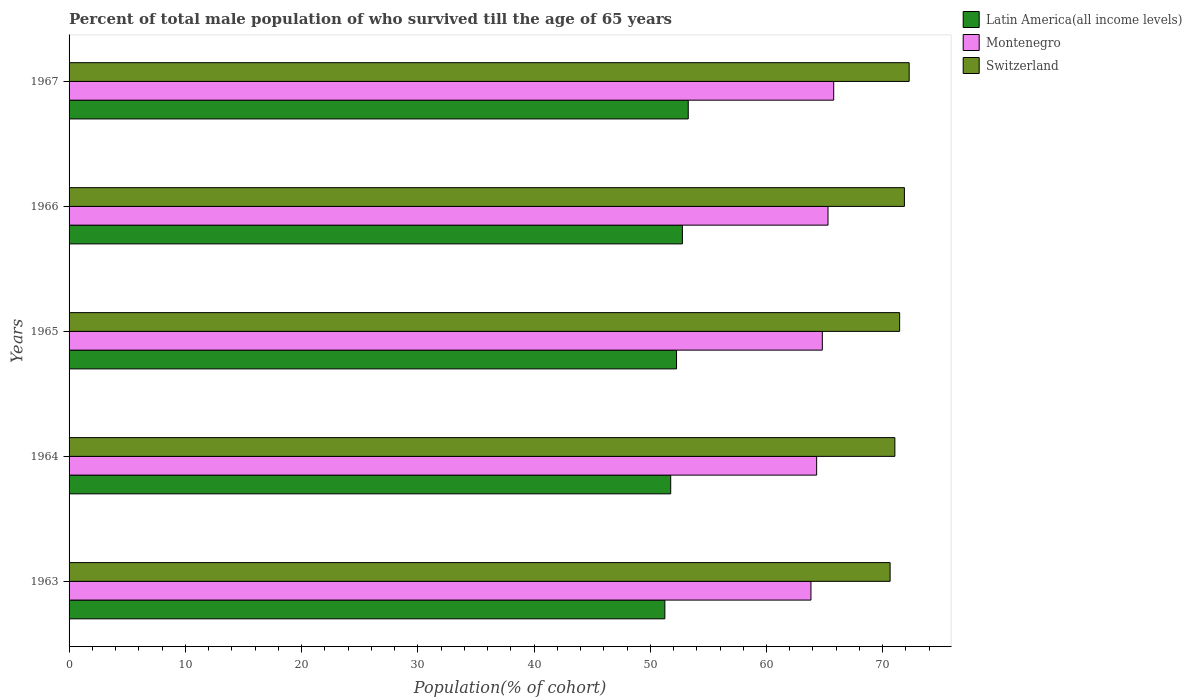How many different coloured bars are there?
Make the answer very short. 3. How many groups of bars are there?
Make the answer very short. 5. How many bars are there on the 4th tick from the top?
Offer a very short reply. 3. How many bars are there on the 4th tick from the bottom?
Your response must be concise. 3. What is the label of the 4th group of bars from the top?
Your response must be concise. 1964. In how many cases, is the number of bars for a given year not equal to the number of legend labels?
Offer a very short reply. 0. What is the percentage of total male population who survived till the age of 65 years in Montenegro in 1966?
Offer a terse response. 65.29. Across all years, what is the maximum percentage of total male population who survived till the age of 65 years in Montenegro?
Ensure brevity in your answer.  65.78. Across all years, what is the minimum percentage of total male population who survived till the age of 65 years in Latin America(all income levels)?
Your answer should be very brief. 51.26. In which year was the percentage of total male population who survived till the age of 65 years in Switzerland maximum?
Offer a terse response. 1967. In which year was the percentage of total male population who survived till the age of 65 years in Latin America(all income levels) minimum?
Keep it short and to the point. 1963. What is the total percentage of total male population who survived till the age of 65 years in Montenegro in the graph?
Ensure brevity in your answer.  324.02. What is the difference between the percentage of total male population who survived till the age of 65 years in Montenegro in 1963 and that in 1965?
Ensure brevity in your answer.  -0.98. What is the difference between the percentage of total male population who survived till the age of 65 years in Switzerland in 1966 and the percentage of total male population who survived till the age of 65 years in Montenegro in 1965?
Make the answer very short. 7.06. What is the average percentage of total male population who survived till the age of 65 years in Montenegro per year?
Ensure brevity in your answer.  64.8. In the year 1963, what is the difference between the percentage of total male population who survived till the age of 65 years in Montenegro and percentage of total male population who survived till the age of 65 years in Latin America(all income levels)?
Your answer should be compact. 12.57. What is the ratio of the percentage of total male population who survived till the age of 65 years in Montenegro in 1964 to that in 1966?
Your answer should be very brief. 0.99. Is the percentage of total male population who survived till the age of 65 years in Latin America(all income levels) in 1963 less than that in 1967?
Your answer should be very brief. Yes. Is the difference between the percentage of total male population who survived till the age of 65 years in Montenegro in 1966 and 1967 greater than the difference between the percentage of total male population who survived till the age of 65 years in Latin America(all income levels) in 1966 and 1967?
Your answer should be very brief. Yes. What is the difference between the highest and the second highest percentage of total male population who survived till the age of 65 years in Latin America(all income levels)?
Offer a very short reply. 0.5. What is the difference between the highest and the lowest percentage of total male population who survived till the age of 65 years in Montenegro?
Your answer should be very brief. 1.96. In how many years, is the percentage of total male population who survived till the age of 65 years in Switzerland greater than the average percentage of total male population who survived till the age of 65 years in Switzerland taken over all years?
Keep it short and to the point. 3. What does the 1st bar from the top in 1964 represents?
Ensure brevity in your answer.  Switzerland. What does the 3rd bar from the bottom in 1964 represents?
Offer a terse response. Switzerland. Is it the case that in every year, the sum of the percentage of total male population who survived till the age of 65 years in Montenegro and percentage of total male population who survived till the age of 65 years in Switzerland is greater than the percentage of total male population who survived till the age of 65 years in Latin America(all income levels)?
Provide a succinct answer. Yes. How many bars are there?
Your response must be concise. 15. Are all the bars in the graph horizontal?
Your response must be concise. Yes. How many years are there in the graph?
Provide a succinct answer. 5. Are the values on the major ticks of X-axis written in scientific E-notation?
Offer a very short reply. No. Does the graph contain any zero values?
Your answer should be compact. No. Does the graph contain grids?
Your response must be concise. No. How many legend labels are there?
Offer a very short reply. 3. What is the title of the graph?
Ensure brevity in your answer.  Percent of total male population of who survived till the age of 65 years. Does "Tajikistan" appear as one of the legend labels in the graph?
Offer a terse response. No. What is the label or title of the X-axis?
Offer a terse response. Population(% of cohort). What is the Population(% of cohort) in Latin America(all income levels) in 1963?
Provide a short and direct response. 51.26. What is the Population(% of cohort) of Montenegro in 1963?
Your answer should be compact. 63.83. What is the Population(% of cohort) in Switzerland in 1963?
Offer a terse response. 70.63. What is the Population(% of cohort) in Latin America(all income levels) in 1964?
Offer a very short reply. 51.76. What is the Population(% of cohort) of Montenegro in 1964?
Give a very brief answer. 64.31. What is the Population(% of cohort) in Switzerland in 1964?
Offer a very short reply. 71.04. What is the Population(% of cohort) in Latin America(all income levels) in 1965?
Provide a short and direct response. 52.26. What is the Population(% of cohort) of Montenegro in 1965?
Keep it short and to the point. 64.8. What is the Population(% of cohort) in Switzerland in 1965?
Your answer should be very brief. 71.46. What is the Population(% of cohort) of Latin America(all income levels) in 1966?
Give a very brief answer. 52.76. What is the Population(% of cohort) in Montenegro in 1966?
Provide a short and direct response. 65.29. What is the Population(% of cohort) in Switzerland in 1966?
Provide a short and direct response. 71.87. What is the Population(% of cohort) of Latin America(all income levels) in 1967?
Provide a short and direct response. 53.27. What is the Population(% of cohort) in Montenegro in 1967?
Give a very brief answer. 65.78. What is the Population(% of cohort) in Switzerland in 1967?
Give a very brief answer. 72.28. Across all years, what is the maximum Population(% of cohort) in Latin America(all income levels)?
Offer a very short reply. 53.27. Across all years, what is the maximum Population(% of cohort) of Montenegro?
Make the answer very short. 65.78. Across all years, what is the maximum Population(% of cohort) in Switzerland?
Make the answer very short. 72.28. Across all years, what is the minimum Population(% of cohort) of Latin America(all income levels)?
Ensure brevity in your answer.  51.26. Across all years, what is the minimum Population(% of cohort) in Montenegro?
Your answer should be very brief. 63.83. Across all years, what is the minimum Population(% of cohort) of Switzerland?
Offer a terse response. 70.63. What is the total Population(% of cohort) in Latin America(all income levels) in the graph?
Give a very brief answer. 261.31. What is the total Population(% of cohort) of Montenegro in the graph?
Provide a succinct answer. 324.02. What is the total Population(% of cohort) in Switzerland in the graph?
Keep it short and to the point. 357.28. What is the difference between the Population(% of cohort) of Latin America(all income levels) in 1963 and that in 1964?
Your answer should be very brief. -0.5. What is the difference between the Population(% of cohort) in Montenegro in 1963 and that in 1964?
Provide a short and direct response. -0.49. What is the difference between the Population(% of cohort) in Switzerland in 1963 and that in 1964?
Keep it short and to the point. -0.41. What is the difference between the Population(% of cohort) in Latin America(all income levels) in 1963 and that in 1965?
Your answer should be very brief. -1.01. What is the difference between the Population(% of cohort) of Montenegro in 1963 and that in 1965?
Ensure brevity in your answer.  -0.98. What is the difference between the Population(% of cohort) of Switzerland in 1963 and that in 1965?
Your answer should be compact. -0.82. What is the difference between the Population(% of cohort) of Latin America(all income levels) in 1963 and that in 1966?
Provide a succinct answer. -1.51. What is the difference between the Population(% of cohort) in Montenegro in 1963 and that in 1966?
Your answer should be very brief. -1.47. What is the difference between the Population(% of cohort) in Switzerland in 1963 and that in 1966?
Give a very brief answer. -1.23. What is the difference between the Population(% of cohort) of Latin America(all income levels) in 1963 and that in 1967?
Your response must be concise. -2.01. What is the difference between the Population(% of cohort) of Montenegro in 1963 and that in 1967?
Ensure brevity in your answer.  -1.96. What is the difference between the Population(% of cohort) of Switzerland in 1963 and that in 1967?
Offer a terse response. -1.64. What is the difference between the Population(% of cohort) in Latin America(all income levels) in 1964 and that in 1965?
Your response must be concise. -0.5. What is the difference between the Population(% of cohort) of Montenegro in 1964 and that in 1965?
Provide a short and direct response. -0.49. What is the difference between the Population(% of cohort) of Switzerland in 1964 and that in 1965?
Keep it short and to the point. -0.41. What is the difference between the Population(% of cohort) of Latin America(all income levels) in 1964 and that in 1966?
Your answer should be very brief. -1.01. What is the difference between the Population(% of cohort) of Montenegro in 1964 and that in 1966?
Offer a terse response. -0.98. What is the difference between the Population(% of cohort) of Switzerland in 1964 and that in 1966?
Your answer should be compact. -0.82. What is the difference between the Population(% of cohort) of Latin America(all income levels) in 1964 and that in 1967?
Make the answer very short. -1.51. What is the difference between the Population(% of cohort) in Montenegro in 1964 and that in 1967?
Your answer should be compact. -1.47. What is the difference between the Population(% of cohort) in Switzerland in 1964 and that in 1967?
Keep it short and to the point. -1.23. What is the difference between the Population(% of cohort) of Latin America(all income levels) in 1965 and that in 1966?
Your answer should be compact. -0.5. What is the difference between the Population(% of cohort) of Montenegro in 1965 and that in 1966?
Offer a very short reply. -0.49. What is the difference between the Population(% of cohort) in Switzerland in 1965 and that in 1966?
Provide a short and direct response. -0.41. What is the difference between the Population(% of cohort) of Latin America(all income levels) in 1965 and that in 1967?
Keep it short and to the point. -1.01. What is the difference between the Population(% of cohort) of Montenegro in 1965 and that in 1967?
Provide a short and direct response. -0.98. What is the difference between the Population(% of cohort) in Switzerland in 1965 and that in 1967?
Provide a succinct answer. -0.82. What is the difference between the Population(% of cohort) in Latin America(all income levels) in 1966 and that in 1967?
Make the answer very short. -0.5. What is the difference between the Population(% of cohort) of Montenegro in 1966 and that in 1967?
Ensure brevity in your answer.  -0.49. What is the difference between the Population(% of cohort) of Switzerland in 1966 and that in 1967?
Offer a terse response. -0.41. What is the difference between the Population(% of cohort) of Latin America(all income levels) in 1963 and the Population(% of cohort) of Montenegro in 1964?
Make the answer very short. -13.06. What is the difference between the Population(% of cohort) in Latin America(all income levels) in 1963 and the Population(% of cohort) in Switzerland in 1964?
Offer a very short reply. -19.79. What is the difference between the Population(% of cohort) in Montenegro in 1963 and the Population(% of cohort) in Switzerland in 1964?
Ensure brevity in your answer.  -7.22. What is the difference between the Population(% of cohort) in Latin America(all income levels) in 1963 and the Population(% of cohort) in Montenegro in 1965?
Your answer should be compact. -13.55. What is the difference between the Population(% of cohort) of Latin America(all income levels) in 1963 and the Population(% of cohort) of Switzerland in 1965?
Your response must be concise. -20.2. What is the difference between the Population(% of cohort) of Montenegro in 1963 and the Population(% of cohort) of Switzerland in 1965?
Make the answer very short. -7.63. What is the difference between the Population(% of cohort) of Latin America(all income levels) in 1963 and the Population(% of cohort) of Montenegro in 1966?
Keep it short and to the point. -14.04. What is the difference between the Population(% of cohort) in Latin America(all income levels) in 1963 and the Population(% of cohort) in Switzerland in 1966?
Ensure brevity in your answer.  -20.61. What is the difference between the Population(% of cohort) in Montenegro in 1963 and the Population(% of cohort) in Switzerland in 1966?
Ensure brevity in your answer.  -8.04. What is the difference between the Population(% of cohort) of Latin America(all income levels) in 1963 and the Population(% of cohort) of Montenegro in 1967?
Provide a short and direct response. -14.53. What is the difference between the Population(% of cohort) in Latin America(all income levels) in 1963 and the Population(% of cohort) in Switzerland in 1967?
Your answer should be compact. -21.02. What is the difference between the Population(% of cohort) in Montenegro in 1963 and the Population(% of cohort) in Switzerland in 1967?
Offer a very short reply. -8.45. What is the difference between the Population(% of cohort) in Latin America(all income levels) in 1964 and the Population(% of cohort) in Montenegro in 1965?
Make the answer very short. -13.04. What is the difference between the Population(% of cohort) in Latin America(all income levels) in 1964 and the Population(% of cohort) in Switzerland in 1965?
Your response must be concise. -19.7. What is the difference between the Population(% of cohort) of Montenegro in 1964 and the Population(% of cohort) of Switzerland in 1965?
Offer a terse response. -7.14. What is the difference between the Population(% of cohort) in Latin America(all income levels) in 1964 and the Population(% of cohort) in Montenegro in 1966?
Your answer should be very brief. -13.53. What is the difference between the Population(% of cohort) in Latin America(all income levels) in 1964 and the Population(% of cohort) in Switzerland in 1966?
Your answer should be compact. -20.11. What is the difference between the Population(% of cohort) of Montenegro in 1964 and the Population(% of cohort) of Switzerland in 1966?
Your response must be concise. -7.55. What is the difference between the Population(% of cohort) of Latin America(all income levels) in 1964 and the Population(% of cohort) of Montenegro in 1967?
Keep it short and to the point. -14.02. What is the difference between the Population(% of cohort) of Latin America(all income levels) in 1964 and the Population(% of cohort) of Switzerland in 1967?
Make the answer very short. -20.52. What is the difference between the Population(% of cohort) in Montenegro in 1964 and the Population(% of cohort) in Switzerland in 1967?
Offer a very short reply. -7.96. What is the difference between the Population(% of cohort) of Latin America(all income levels) in 1965 and the Population(% of cohort) of Montenegro in 1966?
Make the answer very short. -13.03. What is the difference between the Population(% of cohort) of Latin America(all income levels) in 1965 and the Population(% of cohort) of Switzerland in 1966?
Provide a short and direct response. -19.6. What is the difference between the Population(% of cohort) in Montenegro in 1965 and the Population(% of cohort) in Switzerland in 1966?
Make the answer very short. -7.06. What is the difference between the Population(% of cohort) in Latin America(all income levels) in 1965 and the Population(% of cohort) in Montenegro in 1967?
Give a very brief answer. -13.52. What is the difference between the Population(% of cohort) of Latin America(all income levels) in 1965 and the Population(% of cohort) of Switzerland in 1967?
Provide a short and direct response. -20.01. What is the difference between the Population(% of cohort) in Montenegro in 1965 and the Population(% of cohort) in Switzerland in 1967?
Provide a succinct answer. -7.47. What is the difference between the Population(% of cohort) of Latin America(all income levels) in 1966 and the Population(% of cohort) of Montenegro in 1967?
Ensure brevity in your answer.  -13.02. What is the difference between the Population(% of cohort) in Latin America(all income levels) in 1966 and the Population(% of cohort) in Switzerland in 1967?
Ensure brevity in your answer.  -19.51. What is the difference between the Population(% of cohort) of Montenegro in 1966 and the Population(% of cohort) of Switzerland in 1967?
Provide a succinct answer. -6.98. What is the average Population(% of cohort) in Latin America(all income levels) per year?
Your answer should be compact. 52.26. What is the average Population(% of cohort) of Montenegro per year?
Your answer should be compact. 64.8. What is the average Population(% of cohort) of Switzerland per year?
Provide a succinct answer. 71.46. In the year 1963, what is the difference between the Population(% of cohort) of Latin America(all income levels) and Population(% of cohort) of Montenegro?
Your answer should be very brief. -12.57. In the year 1963, what is the difference between the Population(% of cohort) in Latin America(all income levels) and Population(% of cohort) in Switzerland?
Your answer should be very brief. -19.38. In the year 1963, what is the difference between the Population(% of cohort) of Montenegro and Population(% of cohort) of Switzerland?
Your answer should be very brief. -6.81. In the year 1964, what is the difference between the Population(% of cohort) of Latin America(all income levels) and Population(% of cohort) of Montenegro?
Keep it short and to the point. -12.56. In the year 1964, what is the difference between the Population(% of cohort) in Latin America(all income levels) and Population(% of cohort) in Switzerland?
Your answer should be very brief. -19.29. In the year 1964, what is the difference between the Population(% of cohort) in Montenegro and Population(% of cohort) in Switzerland?
Ensure brevity in your answer.  -6.73. In the year 1965, what is the difference between the Population(% of cohort) of Latin America(all income levels) and Population(% of cohort) of Montenegro?
Your answer should be compact. -12.54. In the year 1965, what is the difference between the Population(% of cohort) in Latin America(all income levels) and Population(% of cohort) in Switzerland?
Keep it short and to the point. -19.19. In the year 1965, what is the difference between the Population(% of cohort) in Montenegro and Population(% of cohort) in Switzerland?
Offer a terse response. -6.65. In the year 1966, what is the difference between the Population(% of cohort) in Latin America(all income levels) and Population(% of cohort) in Montenegro?
Ensure brevity in your answer.  -12.53. In the year 1966, what is the difference between the Population(% of cohort) in Latin America(all income levels) and Population(% of cohort) in Switzerland?
Your answer should be very brief. -19.1. In the year 1966, what is the difference between the Population(% of cohort) of Montenegro and Population(% of cohort) of Switzerland?
Give a very brief answer. -6.57. In the year 1967, what is the difference between the Population(% of cohort) of Latin America(all income levels) and Population(% of cohort) of Montenegro?
Give a very brief answer. -12.51. In the year 1967, what is the difference between the Population(% of cohort) of Latin America(all income levels) and Population(% of cohort) of Switzerland?
Offer a terse response. -19.01. In the year 1967, what is the difference between the Population(% of cohort) of Montenegro and Population(% of cohort) of Switzerland?
Your answer should be very brief. -6.49. What is the ratio of the Population(% of cohort) in Latin America(all income levels) in 1963 to that in 1964?
Ensure brevity in your answer.  0.99. What is the ratio of the Population(% of cohort) in Montenegro in 1963 to that in 1964?
Provide a succinct answer. 0.99. What is the ratio of the Population(% of cohort) in Switzerland in 1963 to that in 1964?
Keep it short and to the point. 0.99. What is the ratio of the Population(% of cohort) in Latin America(all income levels) in 1963 to that in 1965?
Ensure brevity in your answer.  0.98. What is the ratio of the Population(% of cohort) of Montenegro in 1963 to that in 1965?
Provide a short and direct response. 0.98. What is the ratio of the Population(% of cohort) in Latin America(all income levels) in 1963 to that in 1966?
Your answer should be very brief. 0.97. What is the ratio of the Population(% of cohort) in Montenegro in 1963 to that in 1966?
Offer a very short reply. 0.98. What is the ratio of the Population(% of cohort) of Switzerland in 1963 to that in 1966?
Offer a very short reply. 0.98. What is the ratio of the Population(% of cohort) of Latin America(all income levels) in 1963 to that in 1967?
Offer a terse response. 0.96. What is the ratio of the Population(% of cohort) of Montenegro in 1963 to that in 1967?
Make the answer very short. 0.97. What is the ratio of the Population(% of cohort) of Switzerland in 1963 to that in 1967?
Your response must be concise. 0.98. What is the ratio of the Population(% of cohort) in Latin America(all income levels) in 1964 to that in 1965?
Ensure brevity in your answer.  0.99. What is the ratio of the Population(% of cohort) of Latin America(all income levels) in 1964 to that in 1966?
Keep it short and to the point. 0.98. What is the ratio of the Population(% of cohort) of Montenegro in 1964 to that in 1966?
Provide a short and direct response. 0.98. What is the ratio of the Population(% of cohort) of Switzerland in 1964 to that in 1966?
Your answer should be compact. 0.99. What is the ratio of the Population(% of cohort) in Latin America(all income levels) in 1964 to that in 1967?
Your answer should be compact. 0.97. What is the ratio of the Population(% of cohort) in Montenegro in 1964 to that in 1967?
Provide a short and direct response. 0.98. What is the ratio of the Population(% of cohort) of Latin America(all income levels) in 1965 to that in 1966?
Your answer should be very brief. 0.99. What is the ratio of the Population(% of cohort) in Switzerland in 1965 to that in 1966?
Provide a short and direct response. 0.99. What is the ratio of the Population(% of cohort) in Latin America(all income levels) in 1965 to that in 1967?
Give a very brief answer. 0.98. What is the ratio of the Population(% of cohort) in Montenegro in 1965 to that in 1967?
Provide a short and direct response. 0.99. What is the ratio of the Population(% of cohort) in Switzerland in 1965 to that in 1967?
Keep it short and to the point. 0.99. What is the ratio of the Population(% of cohort) of Latin America(all income levels) in 1966 to that in 1967?
Ensure brevity in your answer.  0.99. What is the ratio of the Population(% of cohort) of Montenegro in 1966 to that in 1967?
Ensure brevity in your answer.  0.99. What is the difference between the highest and the second highest Population(% of cohort) in Latin America(all income levels)?
Your answer should be compact. 0.5. What is the difference between the highest and the second highest Population(% of cohort) of Montenegro?
Offer a very short reply. 0.49. What is the difference between the highest and the second highest Population(% of cohort) in Switzerland?
Offer a terse response. 0.41. What is the difference between the highest and the lowest Population(% of cohort) of Latin America(all income levels)?
Make the answer very short. 2.01. What is the difference between the highest and the lowest Population(% of cohort) of Montenegro?
Provide a succinct answer. 1.96. What is the difference between the highest and the lowest Population(% of cohort) in Switzerland?
Make the answer very short. 1.64. 